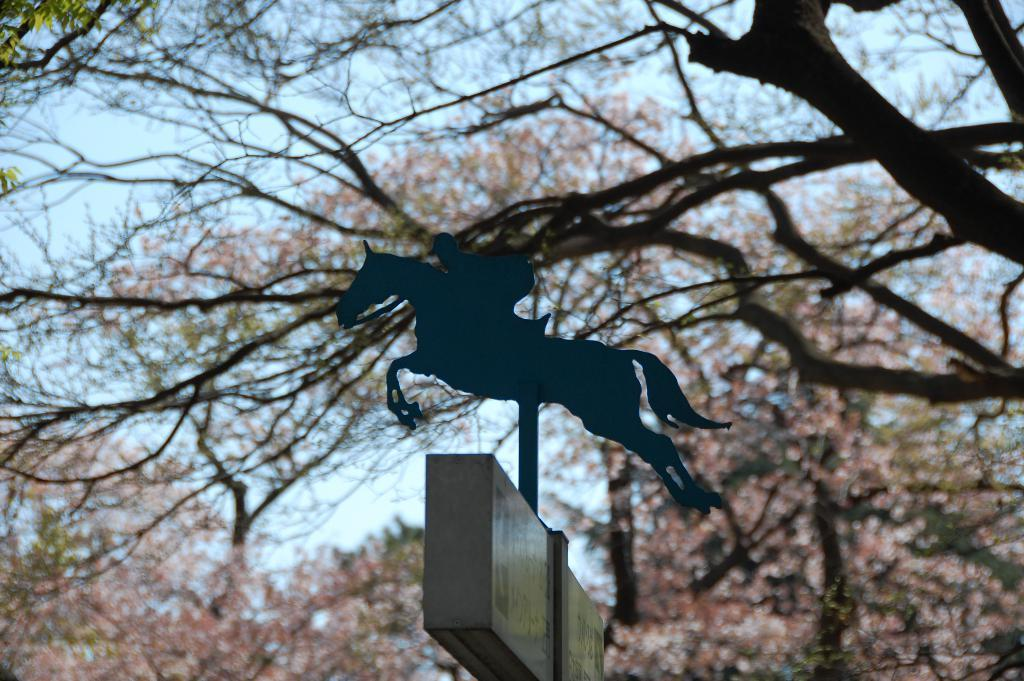What is the main object in the image? There is a board in the image. What other object can be seen in the image? There is a pole in the image. What type of natural elements are present in the image? There are trees in the image. What symbol or design is featured in the image? The logo of a person riding a horse is present in the image. What can be seen in the background of the image? The sky is visible in the background of the image. What type of butter is being used to grease the pole in the image? There is no butter present in the image, nor is there any indication of the pole being greased. 